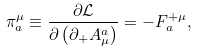<formula> <loc_0><loc_0><loc_500><loc_500>\pi _ { a } ^ { \mu } \equiv \frac { \partial \mathcal { L } } { \partial \left ( \partial _ { + } A _ { \mu } ^ { a } \right ) } = - F _ { a } ^ { + \mu } ,</formula> 